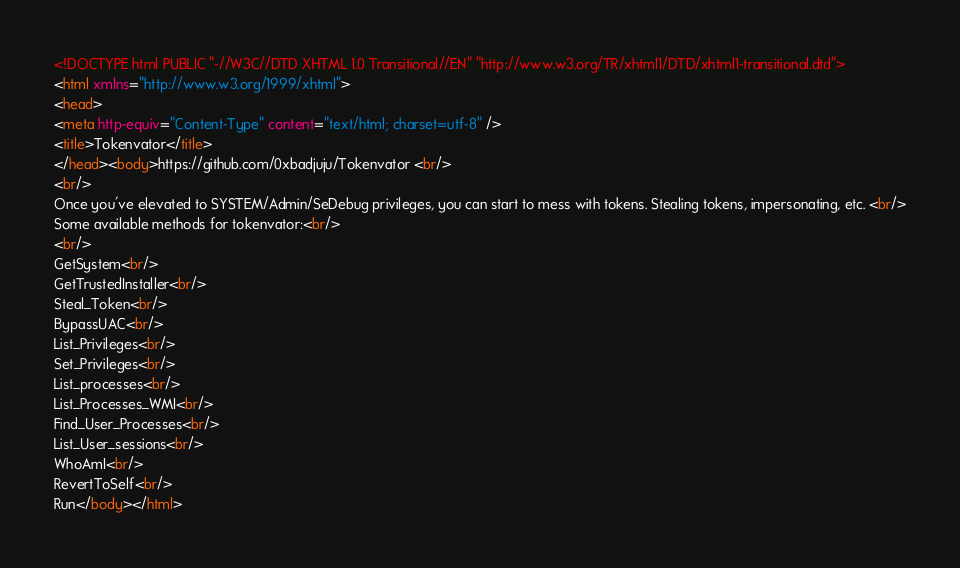Convert code to text. <code><loc_0><loc_0><loc_500><loc_500><_HTML_><!DOCTYPE html PUBLIC "-//W3C//DTD XHTML 1.0 Transitional//EN" "http://www.w3.org/TR/xhtml1/DTD/xhtml1-transitional.dtd">
<html xmlns="http://www.w3.org/1999/xhtml">
<head>
<meta http-equiv="Content-Type" content="text/html; charset=utf-8" />
<title>Tokenvator</title>
</head><body>https://github.com/0xbadjuju/Tokenvator <br/>
<br/>
Once you've elevated to SYSTEM/Admin/SeDebug privileges, you can start to mess with tokens. Stealing tokens, impersonating, etc. <br/>
Some available methods for tokenvator:<br/>
<br/>
GetSystem<br/>
GetTrustedInstaller<br/>
Steal_Token<br/>
BypassUAC<br/>
List_Privileges<br/>
Set_Privileges<br/>
List_processes<br/>
List_Processes_WMI<br/>
Find_User_Processes<br/>
List_User_sessions<br/>
WhoAmI<br/>
RevertToSelf<br/>
Run</body></html></code> 